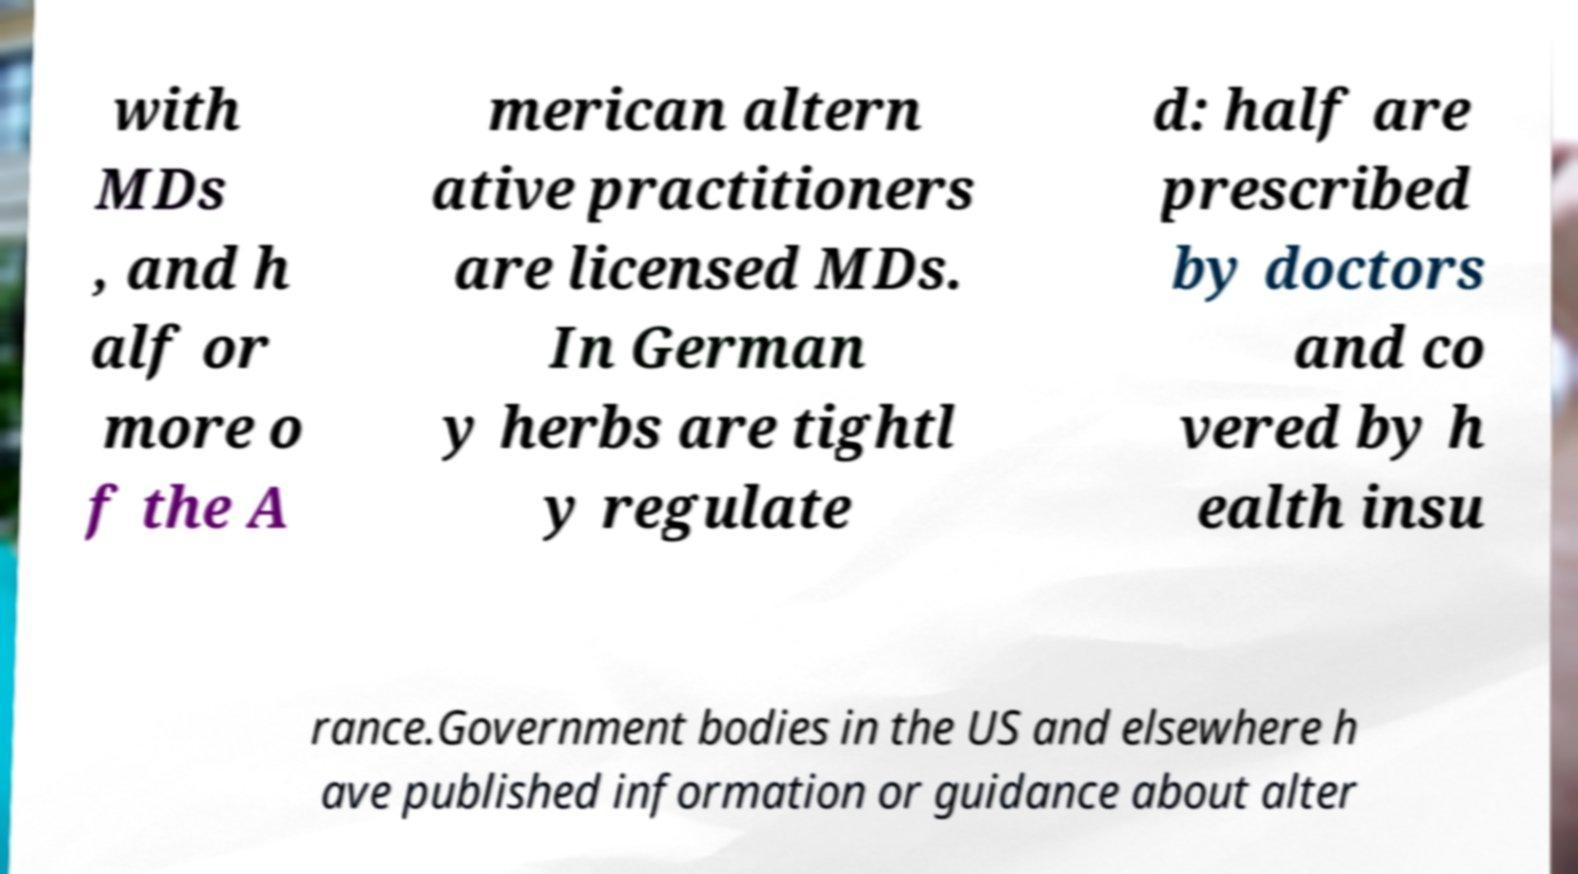For documentation purposes, I need the text within this image transcribed. Could you provide that? with MDs , and h alf or more o f the A merican altern ative practitioners are licensed MDs. In German y herbs are tightl y regulate d: half are prescribed by doctors and co vered by h ealth insu rance.Government bodies in the US and elsewhere h ave published information or guidance about alter 